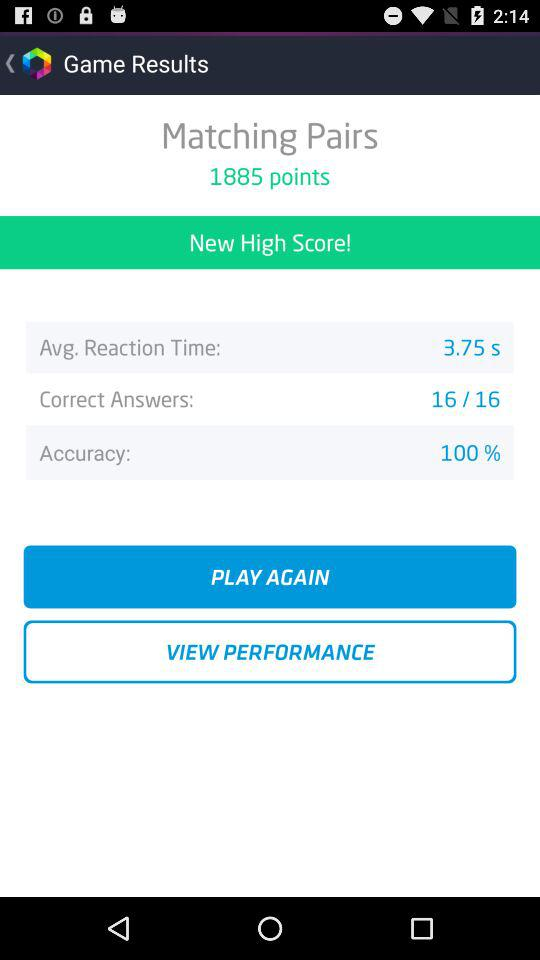What is the % of accuracy? The accuracy is 100%. 